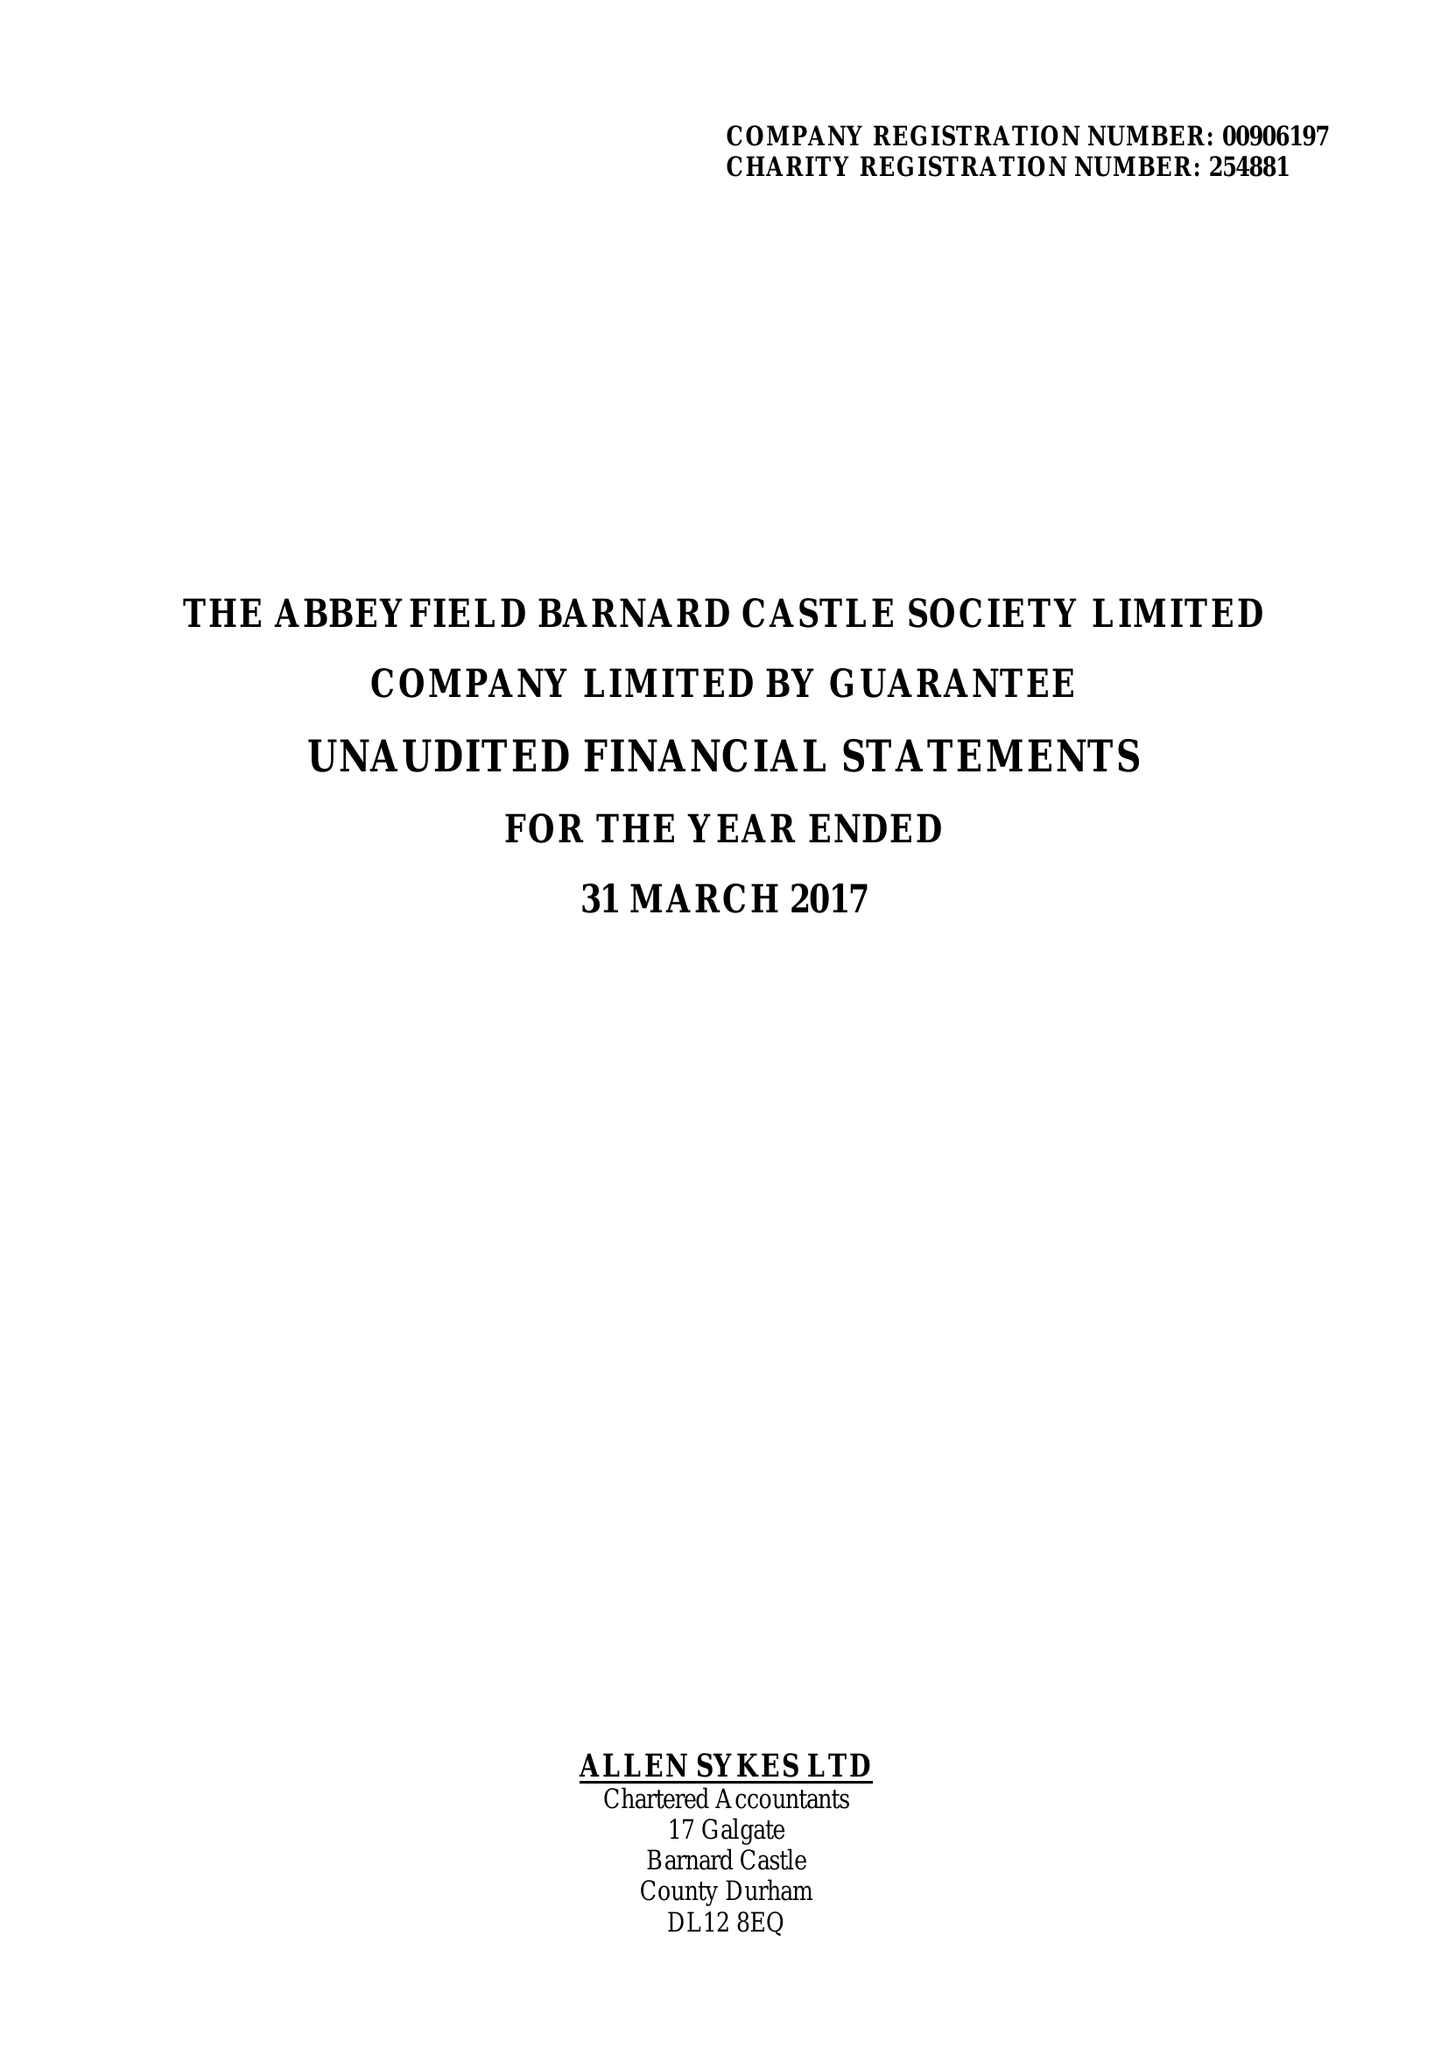What is the value for the spending_annually_in_british_pounds?
Answer the question using a single word or phrase. 154221.00 